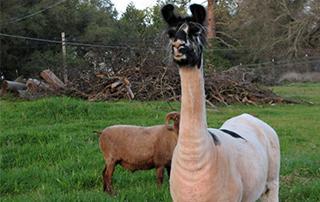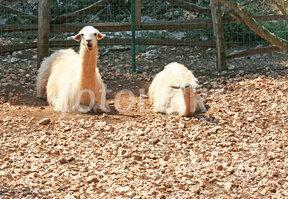The first image is the image on the left, the second image is the image on the right. Considering the images on both sides, is "One image shows two alpacas sitting next to each other." valid? Answer yes or no. Yes. The first image is the image on the left, the second image is the image on the right. Assess this claim about the two images: "One image includes a forward-facing standing llama, and the other image includes a reclining llama with another llama alongside it.". Correct or not? Answer yes or no. Yes. 